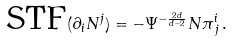Convert formula to latex. <formula><loc_0><loc_0><loc_500><loc_500>\text {STF} ( \partial _ { i } N ^ { j } ) = - \Psi ^ { - \frac { 2 d } { d - 2 } } N \pi ^ { i } _ { \, j } \, .</formula> 